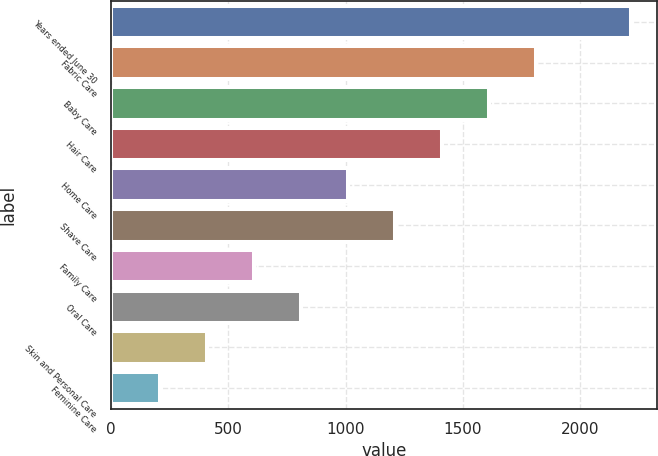<chart> <loc_0><loc_0><loc_500><loc_500><bar_chart><fcel>Years ended June 30<fcel>Fabric Care<fcel>Baby Care<fcel>Hair Care<fcel>Home Care<fcel>Shave Care<fcel>Family Care<fcel>Oral Care<fcel>Skin and Personal Care<fcel>Feminine Care<nl><fcel>2216<fcel>1814<fcel>1613<fcel>1412<fcel>1010<fcel>1211<fcel>608<fcel>809<fcel>407<fcel>206<nl></chart> 